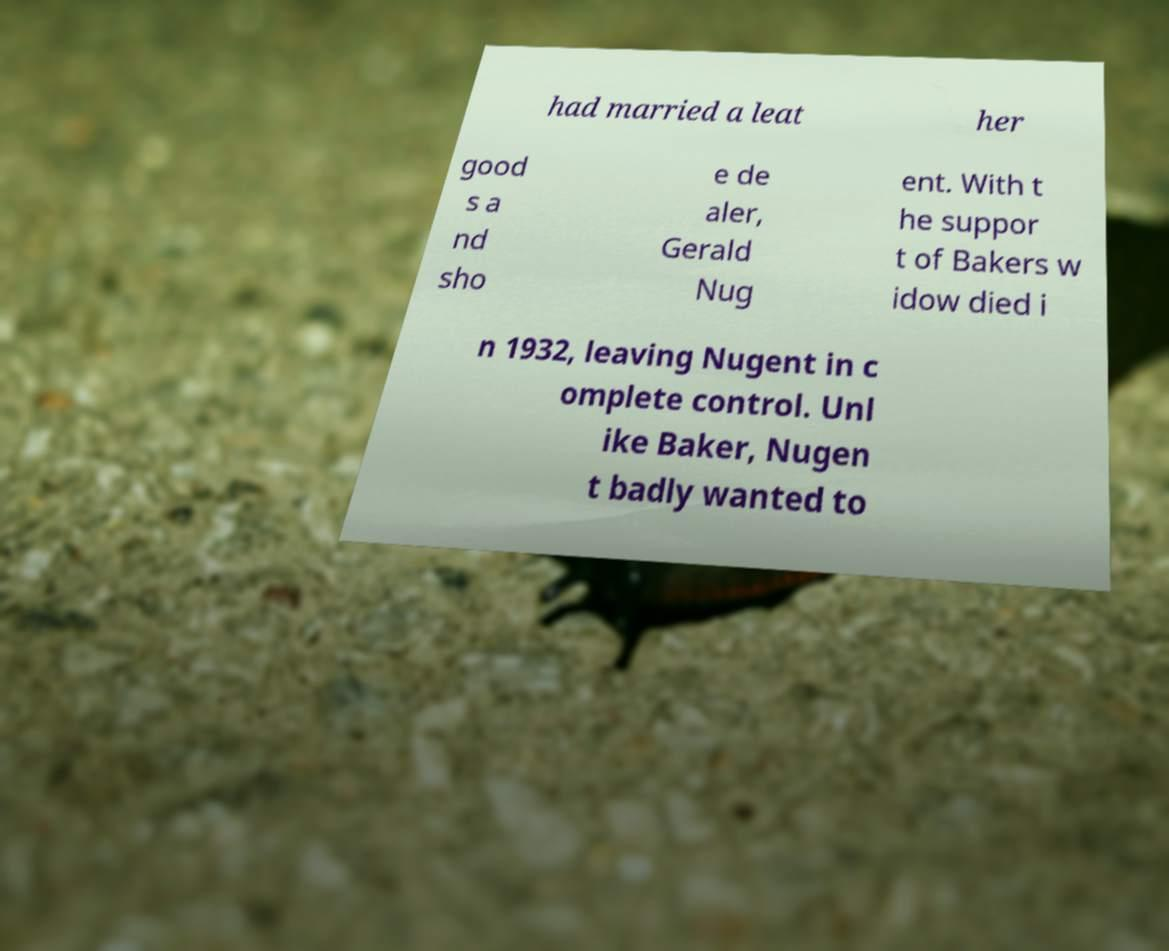I need the written content from this picture converted into text. Can you do that? had married a leat her good s a nd sho e de aler, Gerald Nug ent. With t he suppor t of Bakers w idow died i n 1932, leaving Nugent in c omplete control. Unl ike Baker, Nugen t badly wanted to 